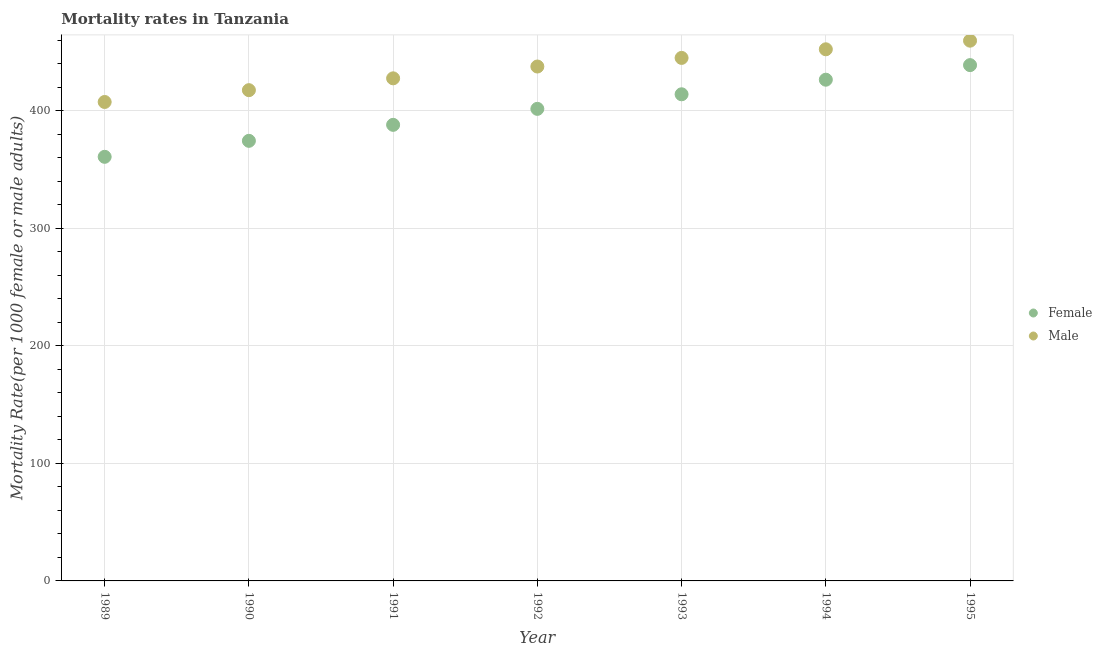How many different coloured dotlines are there?
Your answer should be very brief. 2. What is the female mortality rate in 1995?
Keep it short and to the point. 438.96. Across all years, what is the maximum male mortality rate?
Ensure brevity in your answer.  459.76. Across all years, what is the minimum female mortality rate?
Keep it short and to the point. 360.92. In which year was the female mortality rate minimum?
Offer a terse response. 1989. What is the total female mortality rate in the graph?
Offer a very short reply. 2804.98. What is the difference between the female mortality rate in 1991 and that in 1995?
Ensure brevity in your answer.  -50.83. What is the difference between the female mortality rate in 1995 and the male mortality rate in 1992?
Keep it short and to the point. 1.19. What is the average female mortality rate per year?
Make the answer very short. 400.71. In the year 1994, what is the difference between the female mortality rate and male mortality rate?
Your answer should be compact. -25.88. In how many years, is the male mortality rate greater than 440?
Provide a succinct answer. 3. What is the ratio of the female mortality rate in 1989 to that in 1990?
Offer a very short reply. 0.96. What is the difference between the highest and the second highest female mortality rate?
Provide a succinct answer. 12.41. What is the difference between the highest and the lowest male mortality rate?
Provide a succinct answer. 52.17. Does the male mortality rate monotonically increase over the years?
Your response must be concise. Yes. What is the difference between two consecutive major ticks on the Y-axis?
Ensure brevity in your answer.  100. Does the graph contain any zero values?
Give a very brief answer. No. Does the graph contain grids?
Give a very brief answer. Yes. Where does the legend appear in the graph?
Make the answer very short. Center right. How are the legend labels stacked?
Your answer should be compact. Vertical. What is the title of the graph?
Make the answer very short. Mortality rates in Tanzania. Does "Constant 2005 US$" appear as one of the legend labels in the graph?
Your response must be concise. No. What is the label or title of the X-axis?
Give a very brief answer. Year. What is the label or title of the Y-axis?
Your response must be concise. Mortality Rate(per 1000 female or male adults). What is the Mortality Rate(per 1000 female or male adults) in Female in 1989?
Your answer should be compact. 360.92. What is the Mortality Rate(per 1000 female or male adults) of Male in 1989?
Provide a succinct answer. 407.59. What is the Mortality Rate(per 1000 female or male adults) of Female in 1990?
Ensure brevity in your answer.  374.53. What is the Mortality Rate(per 1000 female or male adults) in Male in 1990?
Ensure brevity in your answer.  417.65. What is the Mortality Rate(per 1000 female or male adults) in Female in 1991?
Offer a very short reply. 388.13. What is the Mortality Rate(per 1000 female or male adults) in Male in 1991?
Keep it short and to the point. 427.71. What is the Mortality Rate(per 1000 female or male adults) of Female in 1992?
Make the answer very short. 401.74. What is the Mortality Rate(per 1000 female or male adults) in Male in 1992?
Your answer should be compact. 437.78. What is the Mortality Rate(per 1000 female or male adults) of Female in 1993?
Give a very brief answer. 414.15. What is the Mortality Rate(per 1000 female or male adults) of Male in 1993?
Your answer should be compact. 445.1. What is the Mortality Rate(per 1000 female or male adults) in Female in 1994?
Offer a terse response. 426.55. What is the Mortality Rate(per 1000 female or male adults) in Male in 1994?
Your answer should be compact. 452.43. What is the Mortality Rate(per 1000 female or male adults) of Female in 1995?
Keep it short and to the point. 438.96. What is the Mortality Rate(per 1000 female or male adults) in Male in 1995?
Keep it short and to the point. 459.76. Across all years, what is the maximum Mortality Rate(per 1000 female or male adults) of Female?
Your response must be concise. 438.96. Across all years, what is the maximum Mortality Rate(per 1000 female or male adults) in Male?
Provide a short and direct response. 459.76. Across all years, what is the minimum Mortality Rate(per 1000 female or male adults) of Female?
Offer a terse response. 360.92. Across all years, what is the minimum Mortality Rate(per 1000 female or male adults) of Male?
Offer a terse response. 407.59. What is the total Mortality Rate(per 1000 female or male adults) in Female in the graph?
Your answer should be very brief. 2804.99. What is the total Mortality Rate(per 1000 female or male adults) in Male in the graph?
Your answer should be compact. 3048.03. What is the difference between the Mortality Rate(per 1000 female or male adults) of Female in 1989 and that in 1990?
Your answer should be compact. -13.61. What is the difference between the Mortality Rate(per 1000 female or male adults) in Male in 1989 and that in 1990?
Ensure brevity in your answer.  -10.06. What is the difference between the Mortality Rate(per 1000 female or male adults) of Female in 1989 and that in 1991?
Give a very brief answer. -27.21. What is the difference between the Mortality Rate(per 1000 female or male adults) of Male in 1989 and that in 1991?
Provide a short and direct response. -20.12. What is the difference between the Mortality Rate(per 1000 female or male adults) of Female in 1989 and that in 1992?
Give a very brief answer. -40.82. What is the difference between the Mortality Rate(per 1000 female or male adults) of Male in 1989 and that in 1992?
Provide a succinct answer. -30.18. What is the difference between the Mortality Rate(per 1000 female or male adults) in Female in 1989 and that in 1993?
Keep it short and to the point. -53.23. What is the difference between the Mortality Rate(per 1000 female or male adults) of Male in 1989 and that in 1993?
Make the answer very short. -37.51. What is the difference between the Mortality Rate(per 1000 female or male adults) of Female in 1989 and that in 1994?
Ensure brevity in your answer.  -65.63. What is the difference between the Mortality Rate(per 1000 female or male adults) of Male in 1989 and that in 1994?
Make the answer very short. -44.84. What is the difference between the Mortality Rate(per 1000 female or male adults) in Female in 1989 and that in 1995?
Keep it short and to the point. -78.04. What is the difference between the Mortality Rate(per 1000 female or male adults) of Male in 1989 and that in 1995?
Offer a terse response. -52.17. What is the difference between the Mortality Rate(per 1000 female or male adults) in Female in 1990 and that in 1991?
Your answer should be very brief. -13.61. What is the difference between the Mortality Rate(per 1000 female or male adults) of Male in 1990 and that in 1991?
Your answer should be compact. -10.06. What is the difference between the Mortality Rate(per 1000 female or male adults) in Female in 1990 and that in 1992?
Offer a terse response. -27.21. What is the difference between the Mortality Rate(per 1000 female or male adults) in Male in 1990 and that in 1992?
Keep it short and to the point. -20.12. What is the difference between the Mortality Rate(per 1000 female or male adults) of Female in 1990 and that in 1993?
Give a very brief answer. -39.62. What is the difference between the Mortality Rate(per 1000 female or male adults) in Male in 1990 and that in 1993?
Offer a very short reply. -27.45. What is the difference between the Mortality Rate(per 1000 female or male adults) of Female in 1990 and that in 1994?
Your response must be concise. -52.03. What is the difference between the Mortality Rate(per 1000 female or male adults) in Male in 1990 and that in 1994?
Give a very brief answer. -34.78. What is the difference between the Mortality Rate(per 1000 female or male adults) of Female in 1990 and that in 1995?
Make the answer very short. -64.44. What is the difference between the Mortality Rate(per 1000 female or male adults) of Male in 1990 and that in 1995?
Offer a very short reply. -42.11. What is the difference between the Mortality Rate(per 1000 female or male adults) of Female in 1991 and that in 1992?
Offer a terse response. -13.61. What is the difference between the Mortality Rate(per 1000 female or male adults) in Male in 1991 and that in 1992?
Make the answer very short. -10.06. What is the difference between the Mortality Rate(per 1000 female or male adults) of Female in 1991 and that in 1993?
Provide a succinct answer. -26.01. What is the difference between the Mortality Rate(per 1000 female or male adults) in Male in 1991 and that in 1993?
Offer a terse response. -17.39. What is the difference between the Mortality Rate(per 1000 female or male adults) of Female in 1991 and that in 1994?
Ensure brevity in your answer.  -38.42. What is the difference between the Mortality Rate(per 1000 female or male adults) of Male in 1991 and that in 1994?
Keep it short and to the point. -24.72. What is the difference between the Mortality Rate(per 1000 female or male adults) of Female in 1991 and that in 1995?
Provide a short and direct response. -50.83. What is the difference between the Mortality Rate(per 1000 female or male adults) in Male in 1991 and that in 1995?
Provide a succinct answer. -32.05. What is the difference between the Mortality Rate(per 1000 female or male adults) of Female in 1992 and that in 1993?
Keep it short and to the point. -12.41. What is the difference between the Mortality Rate(per 1000 female or male adults) of Male in 1992 and that in 1993?
Provide a succinct answer. -7.33. What is the difference between the Mortality Rate(per 1000 female or male adults) of Female in 1992 and that in 1994?
Give a very brief answer. -24.81. What is the difference between the Mortality Rate(per 1000 female or male adults) in Male in 1992 and that in 1994?
Keep it short and to the point. -14.66. What is the difference between the Mortality Rate(per 1000 female or male adults) in Female in 1992 and that in 1995?
Your answer should be compact. -37.22. What is the difference between the Mortality Rate(per 1000 female or male adults) in Male in 1992 and that in 1995?
Offer a terse response. -21.99. What is the difference between the Mortality Rate(per 1000 female or male adults) in Female in 1993 and that in 1994?
Provide a short and direct response. -12.41. What is the difference between the Mortality Rate(per 1000 female or male adults) in Male in 1993 and that in 1994?
Make the answer very short. -7.33. What is the difference between the Mortality Rate(per 1000 female or male adults) in Female in 1993 and that in 1995?
Your response must be concise. -24.82. What is the difference between the Mortality Rate(per 1000 female or male adults) of Male in 1993 and that in 1995?
Your response must be concise. -14.66. What is the difference between the Mortality Rate(per 1000 female or male adults) of Female in 1994 and that in 1995?
Keep it short and to the point. -12.41. What is the difference between the Mortality Rate(per 1000 female or male adults) of Male in 1994 and that in 1995?
Provide a succinct answer. -7.33. What is the difference between the Mortality Rate(per 1000 female or male adults) of Female in 1989 and the Mortality Rate(per 1000 female or male adults) of Male in 1990?
Offer a very short reply. -56.73. What is the difference between the Mortality Rate(per 1000 female or male adults) of Female in 1989 and the Mortality Rate(per 1000 female or male adults) of Male in 1991?
Offer a terse response. -66.79. What is the difference between the Mortality Rate(per 1000 female or male adults) in Female in 1989 and the Mortality Rate(per 1000 female or male adults) in Male in 1992?
Your answer should be very brief. -76.86. What is the difference between the Mortality Rate(per 1000 female or male adults) in Female in 1989 and the Mortality Rate(per 1000 female or male adults) in Male in 1993?
Give a very brief answer. -84.18. What is the difference between the Mortality Rate(per 1000 female or male adults) in Female in 1989 and the Mortality Rate(per 1000 female or male adults) in Male in 1994?
Provide a short and direct response. -91.51. What is the difference between the Mortality Rate(per 1000 female or male adults) in Female in 1989 and the Mortality Rate(per 1000 female or male adults) in Male in 1995?
Make the answer very short. -98.84. What is the difference between the Mortality Rate(per 1000 female or male adults) of Female in 1990 and the Mortality Rate(per 1000 female or male adults) of Male in 1991?
Your answer should be compact. -53.19. What is the difference between the Mortality Rate(per 1000 female or male adults) of Female in 1990 and the Mortality Rate(per 1000 female or male adults) of Male in 1992?
Provide a short and direct response. -63.25. What is the difference between the Mortality Rate(per 1000 female or male adults) in Female in 1990 and the Mortality Rate(per 1000 female or male adults) in Male in 1993?
Give a very brief answer. -70.58. What is the difference between the Mortality Rate(per 1000 female or male adults) in Female in 1990 and the Mortality Rate(per 1000 female or male adults) in Male in 1994?
Give a very brief answer. -77.91. What is the difference between the Mortality Rate(per 1000 female or male adults) in Female in 1990 and the Mortality Rate(per 1000 female or male adults) in Male in 1995?
Give a very brief answer. -85.23. What is the difference between the Mortality Rate(per 1000 female or male adults) of Female in 1991 and the Mortality Rate(per 1000 female or male adults) of Male in 1992?
Give a very brief answer. -49.64. What is the difference between the Mortality Rate(per 1000 female or male adults) in Female in 1991 and the Mortality Rate(per 1000 female or male adults) in Male in 1993?
Offer a terse response. -56.97. What is the difference between the Mortality Rate(per 1000 female or male adults) in Female in 1991 and the Mortality Rate(per 1000 female or male adults) in Male in 1994?
Your answer should be very brief. -64.3. What is the difference between the Mortality Rate(per 1000 female or male adults) in Female in 1991 and the Mortality Rate(per 1000 female or male adults) in Male in 1995?
Make the answer very short. -71.63. What is the difference between the Mortality Rate(per 1000 female or male adults) of Female in 1992 and the Mortality Rate(per 1000 female or male adults) of Male in 1993?
Provide a succinct answer. -43.36. What is the difference between the Mortality Rate(per 1000 female or male adults) of Female in 1992 and the Mortality Rate(per 1000 female or male adults) of Male in 1994?
Provide a succinct answer. -50.69. What is the difference between the Mortality Rate(per 1000 female or male adults) in Female in 1992 and the Mortality Rate(per 1000 female or male adults) in Male in 1995?
Give a very brief answer. -58.02. What is the difference between the Mortality Rate(per 1000 female or male adults) of Female in 1993 and the Mortality Rate(per 1000 female or male adults) of Male in 1994?
Offer a very short reply. -38.29. What is the difference between the Mortality Rate(per 1000 female or male adults) of Female in 1993 and the Mortality Rate(per 1000 female or male adults) of Male in 1995?
Your response must be concise. -45.62. What is the difference between the Mortality Rate(per 1000 female or male adults) of Female in 1994 and the Mortality Rate(per 1000 female or male adults) of Male in 1995?
Your answer should be very brief. -33.21. What is the average Mortality Rate(per 1000 female or male adults) in Female per year?
Make the answer very short. 400.71. What is the average Mortality Rate(per 1000 female or male adults) in Male per year?
Provide a succinct answer. 435.43. In the year 1989, what is the difference between the Mortality Rate(per 1000 female or male adults) in Female and Mortality Rate(per 1000 female or male adults) in Male?
Keep it short and to the point. -46.67. In the year 1990, what is the difference between the Mortality Rate(per 1000 female or male adults) in Female and Mortality Rate(per 1000 female or male adults) in Male?
Offer a very short reply. -43.13. In the year 1991, what is the difference between the Mortality Rate(per 1000 female or male adults) in Female and Mortality Rate(per 1000 female or male adults) in Male?
Offer a very short reply. -39.58. In the year 1992, what is the difference between the Mortality Rate(per 1000 female or male adults) of Female and Mortality Rate(per 1000 female or male adults) of Male?
Provide a short and direct response. -36.04. In the year 1993, what is the difference between the Mortality Rate(per 1000 female or male adults) of Female and Mortality Rate(per 1000 female or male adults) of Male?
Your response must be concise. -30.96. In the year 1994, what is the difference between the Mortality Rate(per 1000 female or male adults) of Female and Mortality Rate(per 1000 female or male adults) of Male?
Your answer should be very brief. -25.88. In the year 1995, what is the difference between the Mortality Rate(per 1000 female or male adults) in Female and Mortality Rate(per 1000 female or male adults) in Male?
Provide a succinct answer. -20.8. What is the ratio of the Mortality Rate(per 1000 female or male adults) of Female in 1989 to that in 1990?
Your response must be concise. 0.96. What is the ratio of the Mortality Rate(per 1000 female or male adults) of Male in 1989 to that in 1990?
Keep it short and to the point. 0.98. What is the ratio of the Mortality Rate(per 1000 female or male adults) of Female in 1989 to that in 1991?
Provide a short and direct response. 0.93. What is the ratio of the Mortality Rate(per 1000 female or male adults) in Male in 1989 to that in 1991?
Give a very brief answer. 0.95. What is the ratio of the Mortality Rate(per 1000 female or male adults) of Female in 1989 to that in 1992?
Offer a very short reply. 0.9. What is the ratio of the Mortality Rate(per 1000 female or male adults) in Male in 1989 to that in 1992?
Give a very brief answer. 0.93. What is the ratio of the Mortality Rate(per 1000 female or male adults) in Female in 1989 to that in 1993?
Offer a very short reply. 0.87. What is the ratio of the Mortality Rate(per 1000 female or male adults) of Male in 1989 to that in 1993?
Your answer should be compact. 0.92. What is the ratio of the Mortality Rate(per 1000 female or male adults) of Female in 1989 to that in 1994?
Your answer should be very brief. 0.85. What is the ratio of the Mortality Rate(per 1000 female or male adults) in Male in 1989 to that in 1994?
Keep it short and to the point. 0.9. What is the ratio of the Mortality Rate(per 1000 female or male adults) of Female in 1989 to that in 1995?
Your answer should be very brief. 0.82. What is the ratio of the Mortality Rate(per 1000 female or male adults) in Male in 1989 to that in 1995?
Provide a succinct answer. 0.89. What is the ratio of the Mortality Rate(per 1000 female or male adults) in Female in 1990 to that in 1991?
Provide a short and direct response. 0.96. What is the ratio of the Mortality Rate(per 1000 female or male adults) of Male in 1990 to that in 1991?
Provide a succinct answer. 0.98. What is the ratio of the Mortality Rate(per 1000 female or male adults) in Female in 1990 to that in 1992?
Your answer should be compact. 0.93. What is the ratio of the Mortality Rate(per 1000 female or male adults) in Male in 1990 to that in 1992?
Give a very brief answer. 0.95. What is the ratio of the Mortality Rate(per 1000 female or male adults) in Female in 1990 to that in 1993?
Provide a succinct answer. 0.9. What is the ratio of the Mortality Rate(per 1000 female or male adults) of Male in 1990 to that in 1993?
Ensure brevity in your answer.  0.94. What is the ratio of the Mortality Rate(per 1000 female or male adults) in Female in 1990 to that in 1994?
Your answer should be compact. 0.88. What is the ratio of the Mortality Rate(per 1000 female or male adults) of Female in 1990 to that in 1995?
Your answer should be compact. 0.85. What is the ratio of the Mortality Rate(per 1000 female or male adults) in Male in 1990 to that in 1995?
Offer a terse response. 0.91. What is the ratio of the Mortality Rate(per 1000 female or male adults) in Female in 1991 to that in 1992?
Your response must be concise. 0.97. What is the ratio of the Mortality Rate(per 1000 female or male adults) of Female in 1991 to that in 1993?
Your answer should be very brief. 0.94. What is the ratio of the Mortality Rate(per 1000 female or male adults) in Male in 1991 to that in 1993?
Offer a very short reply. 0.96. What is the ratio of the Mortality Rate(per 1000 female or male adults) in Female in 1991 to that in 1994?
Offer a very short reply. 0.91. What is the ratio of the Mortality Rate(per 1000 female or male adults) in Male in 1991 to that in 1994?
Your answer should be compact. 0.95. What is the ratio of the Mortality Rate(per 1000 female or male adults) of Female in 1991 to that in 1995?
Keep it short and to the point. 0.88. What is the ratio of the Mortality Rate(per 1000 female or male adults) in Male in 1991 to that in 1995?
Your answer should be compact. 0.93. What is the ratio of the Mortality Rate(per 1000 female or male adults) of Female in 1992 to that in 1993?
Offer a very short reply. 0.97. What is the ratio of the Mortality Rate(per 1000 female or male adults) in Male in 1992 to that in 1993?
Make the answer very short. 0.98. What is the ratio of the Mortality Rate(per 1000 female or male adults) of Female in 1992 to that in 1994?
Provide a succinct answer. 0.94. What is the ratio of the Mortality Rate(per 1000 female or male adults) in Male in 1992 to that in 1994?
Make the answer very short. 0.97. What is the ratio of the Mortality Rate(per 1000 female or male adults) of Female in 1992 to that in 1995?
Offer a terse response. 0.92. What is the ratio of the Mortality Rate(per 1000 female or male adults) of Male in 1992 to that in 1995?
Provide a short and direct response. 0.95. What is the ratio of the Mortality Rate(per 1000 female or male adults) in Female in 1993 to that in 1994?
Provide a succinct answer. 0.97. What is the ratio of the Mortality Rate(per 1000 female or male adults) in Male in 1993 to that in 1994?
Offer a very short reply. 0.98. What is the ratio of the Mortality Rate(per 1000 female or male adults) in Female in 1993 to that in 1995?
Your answer should be compact. 0.94. What is the ratio of the Mortality Rate(per 1000 female or male adults) of Male in 1993 to that in 1995?
Your answer should be compact. 0.97. What is the ratio of the Mortality Rate(per 1000 female or male adults) in Female in 1994 to that in 1995?
Offer a very short reply. 0.97. What is the ratio of the Mortality Rate(per 1000 female or male adults) in Male in 1994 to that in 1995?
Keep it short and to the point. 0.98. What is the difference between the highest and the second highest Mortality Rate(per 1000 female or male adults) of Female?
Your answer should be compact. 12.41. What is the difference between the highest and the second highest Mortality Rate(per 1000 female or male adults) in Male?
Offer a terse response. 7.33. What is the difference between the highest and the lowest Mortality Rate(per 1000 female or male adults) in Female?
Ensure brevity in your answer.  78.04. What is the difference between the highest and the lowest Mortality Rate(per 1000 female or male adults) in Male?
Ensure brevity in your answer.  52.17. 